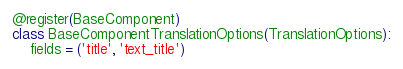Convert code to text. <code><loc_0><loc_0><loc_500><loc_500><_Python_>@register(BaseComponent)
class BaseComponentTranslationOptions(TranslationOptions):
    fields = ('title', 'text_title')
</code> 